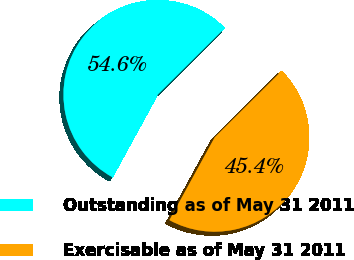Convert chart. <chart><loc_0><loc_0><loc_500><loc_500><pie_chart><fcel>Outstanding as of May 31 2011<fcel>Exercisable as of May 31 2011<nl><fcel>54.59%<fcel>45.41%<nl></chart> 